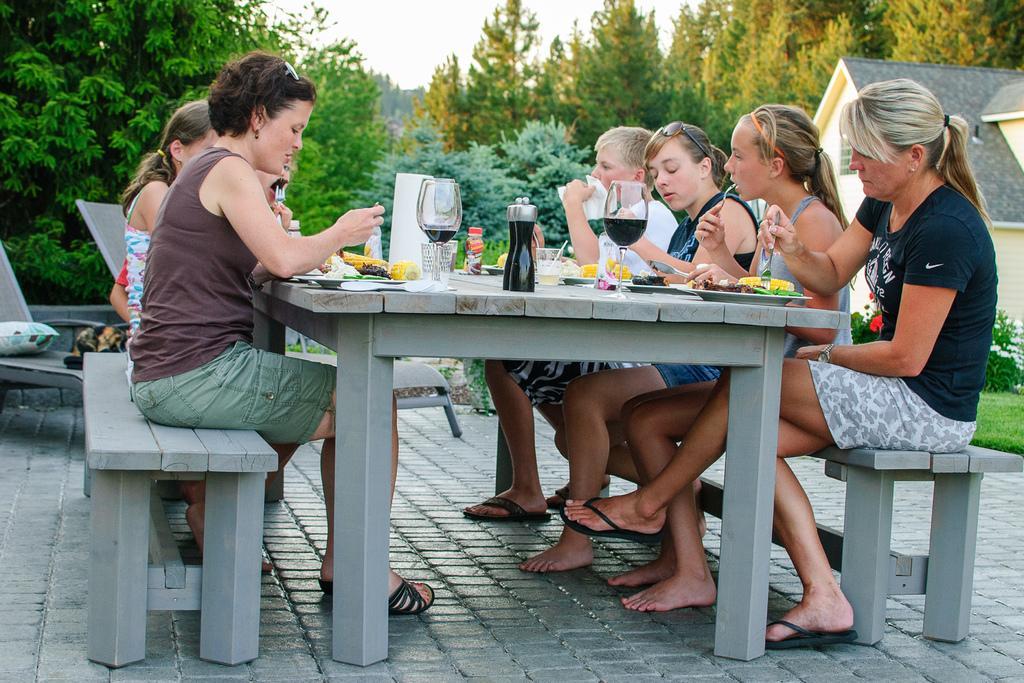Can you describe this image briefly? In the image we can see few persons were sitting on the bench around the table. On table,we can see wine glasses,bottle,plate,tissue paper and food item. In the background there is a sky,trees,building,plant and grass. 